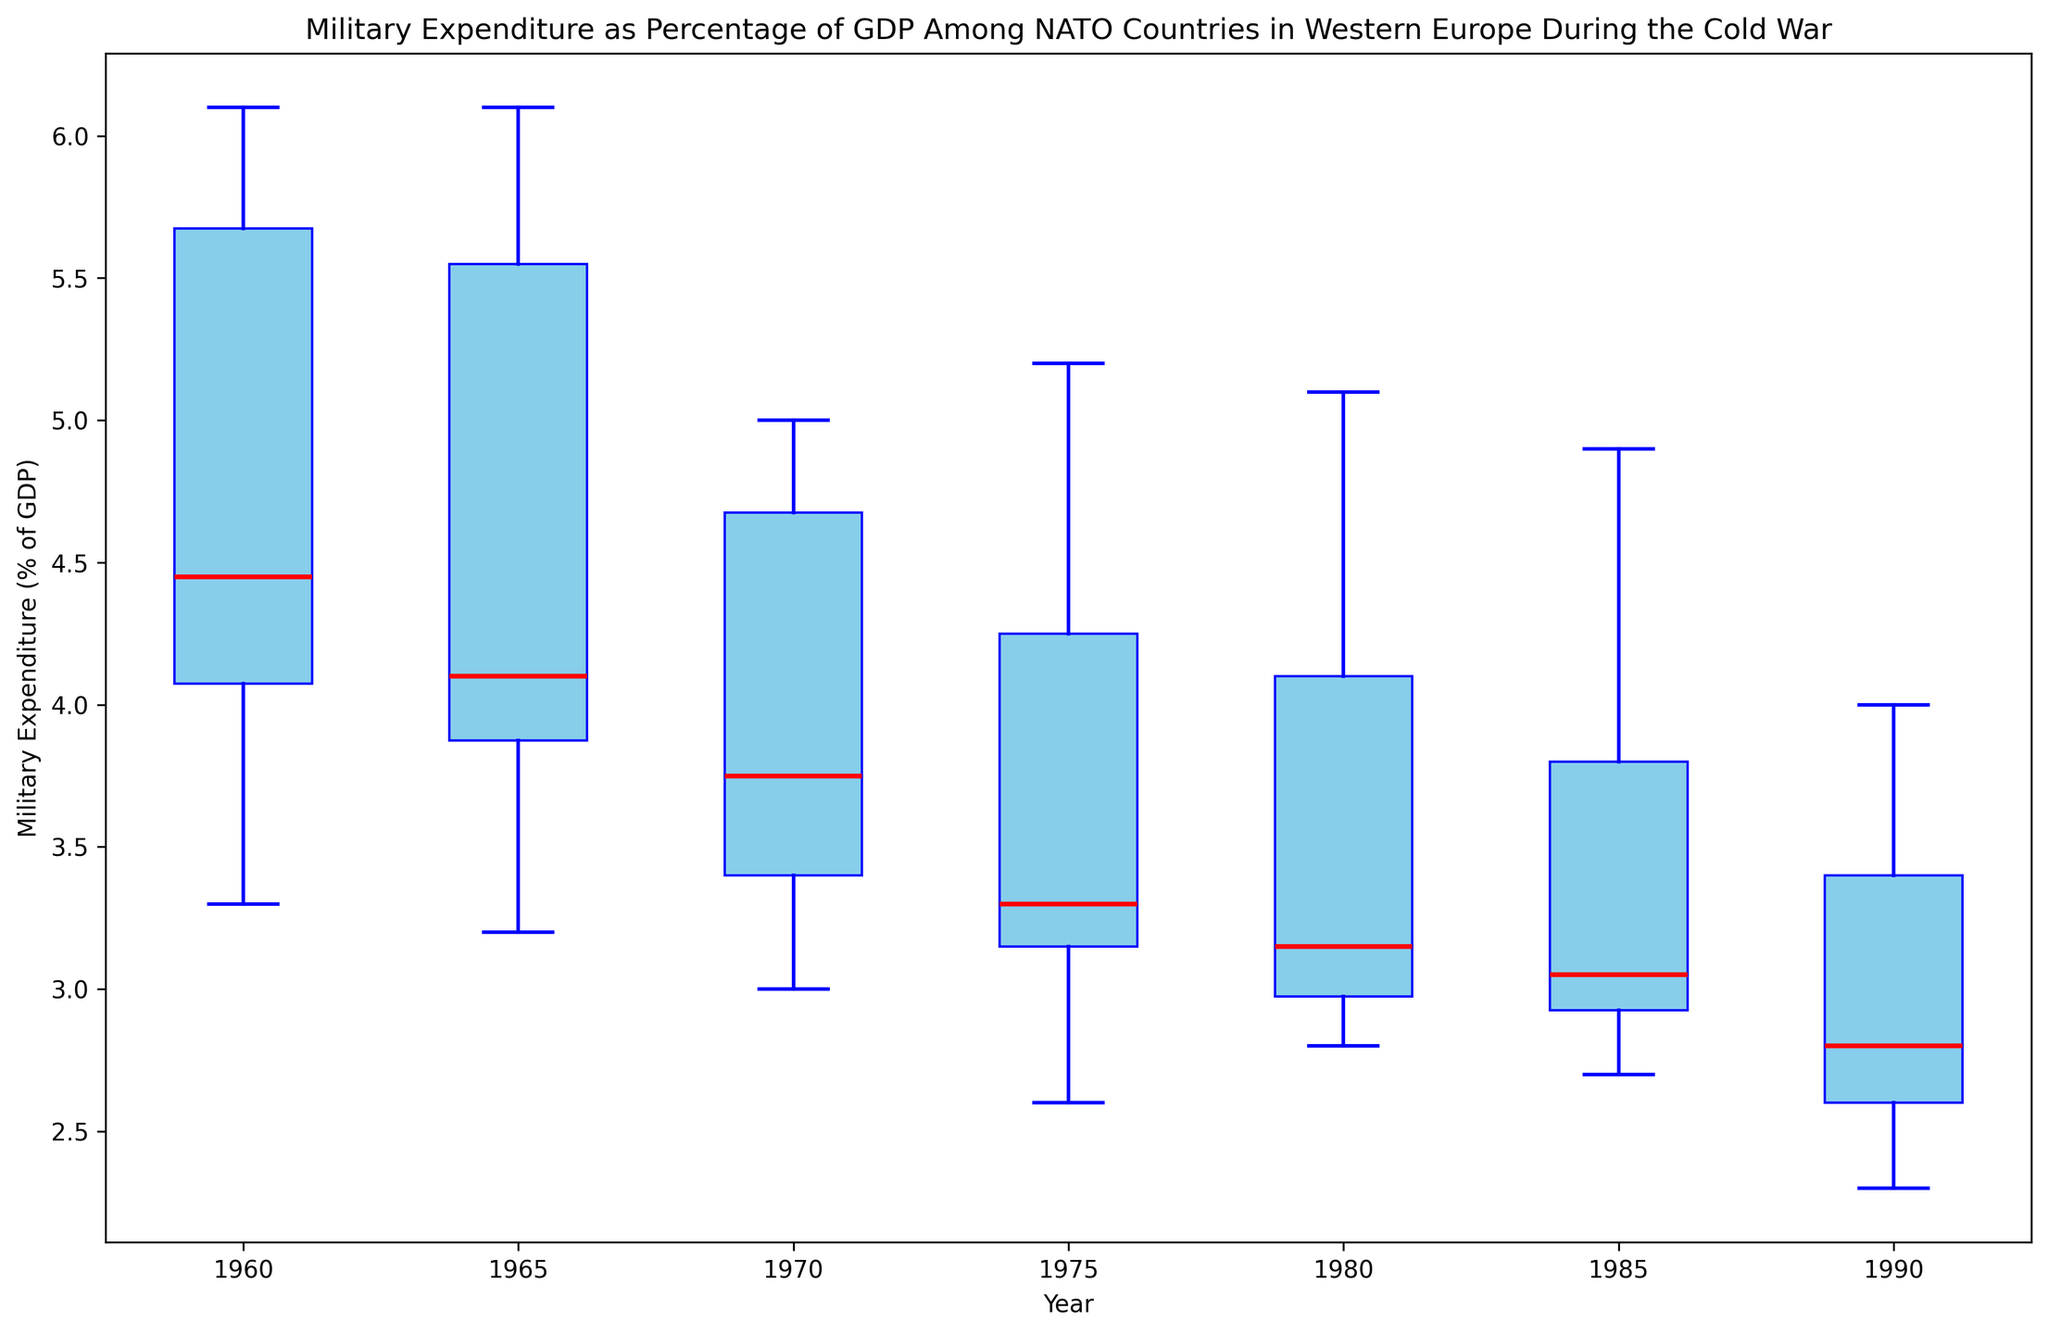What is the median military expenditure as a percentage of GDP for NATO countries in 1960? Identify the box corresponding to the year 1960. The red line inside the box represents the median value. For 1960, the median value of military expenditure is approximately 4.4%.
Answer: 4.4% Which year had the highest average military expenditure as a percentage of GDP? To determine this, look at the boxes and compare the positions and sizes. The year with the highest average military expenditure will have the median line (red line) higher than others. From the plot, 1960 has the highest overall position of the median.
Answer: 1960 Between 1975 and 1990, in which year did NATO countries spend the least on military as a percentage of GDP on average? Compare the medians of the relevant years (red lines). The year with the lowest median will represent the least expenditure on average. Based on the plot, 1990 has the lowest median value.
Answer: 1990 How does the variability in military expenditure as a percentage of GDP compare between 1960 and 1985? Assess the interquartile ranges (heights of the box) and the spread of the whiskers for those years. 1960 shows a larger interquartile range and a greater spread of whiskers compared to 1985, indicating more variability.
Answer: 1960 has more variability What is the trend of military expenditure as a percentage of GDP from 1960 to 1990? Observe the medians across the years. The median value decreases consistently from 1960 to 1990, indicating a declining trend in military expenditure.
Answer: Declining trend Which year had the most consistent (least variable) military expenditure as a percentage of GDP? Identify the box plot with the smallest interquartile range (box height) and shortest whiskers. Based on the figure, 1980 appears to have the most consistent values with the smallest interquartile range and whiskers.
Answer: 1980 How does the military expenditure as a percentage of GDP for 1965 compare to 1970? Identify the medians for 1965 and 1970. The median for 1965 is higher than that for 1970, indicating higher expenditure in 1965.
Answer: 1965 is higher What range did the military expenditure as a percentage of GDP span in 1975? Look at the whiskers' endpoints for the year 1975. Military expenditures ranged from around 2.6% to 5.2%.
Answer: 2.6% to 5.2% Which year shows an outlier in military expenditure data, and what country might that outlier represent? Examine the scatter points outside the whiskers. The figure might show an outlier for a specific year represented as a small dot further from the box. Based on the provided data, 1960 could show an outlier, likely for France with 6.1%.
Answer: 1960, likely France 